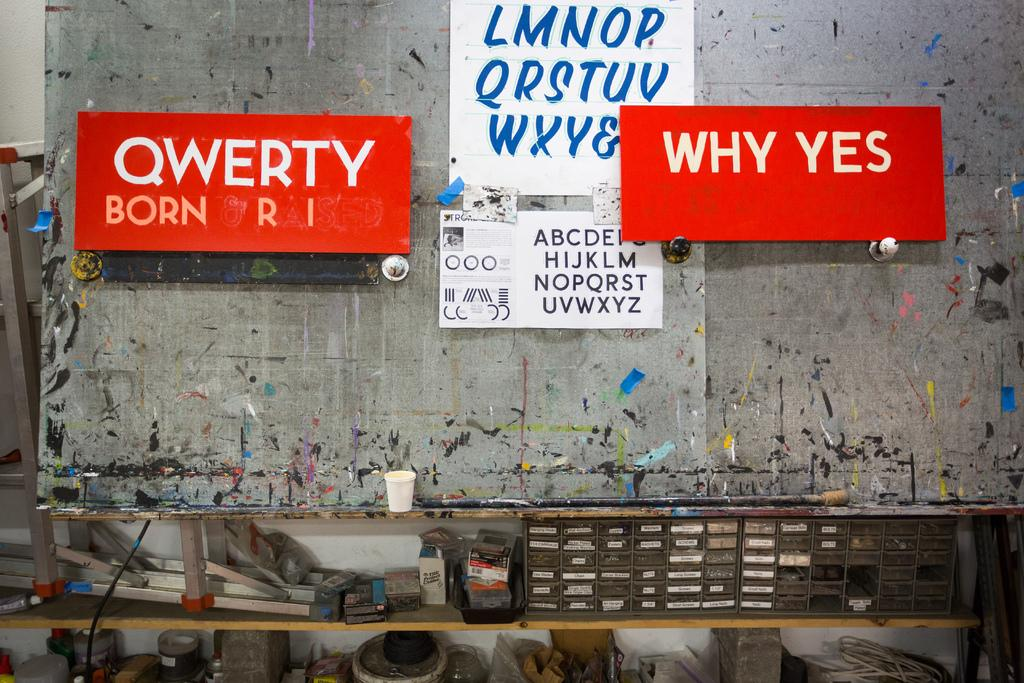What can be seen on the papers in the image? The contents of the papers cannot be determined from the image. What are the name boards attached to in the image? The name boards are attached to a board in the image. What type of container is at the bottom of the image? There is a paper cup at the bottom of the image. What other objects are visible at the bottom of the image? There are other objects visible at the bottom of the image, but their specific nature cannot be determined from the image. Can you see a ladybug skating on the papers in the image? No, there is no ladybug or skating activity present in the image. 